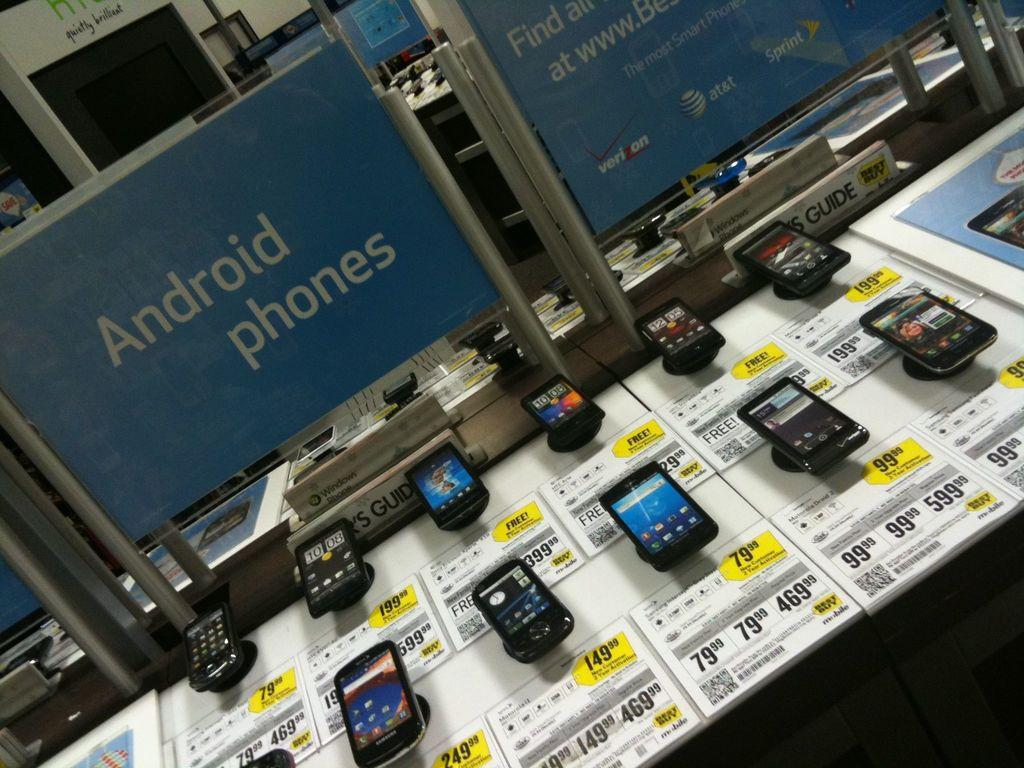<image>
Relay a brief, clear account of the picture shown. A store display of 11 or 12 Android phones. 